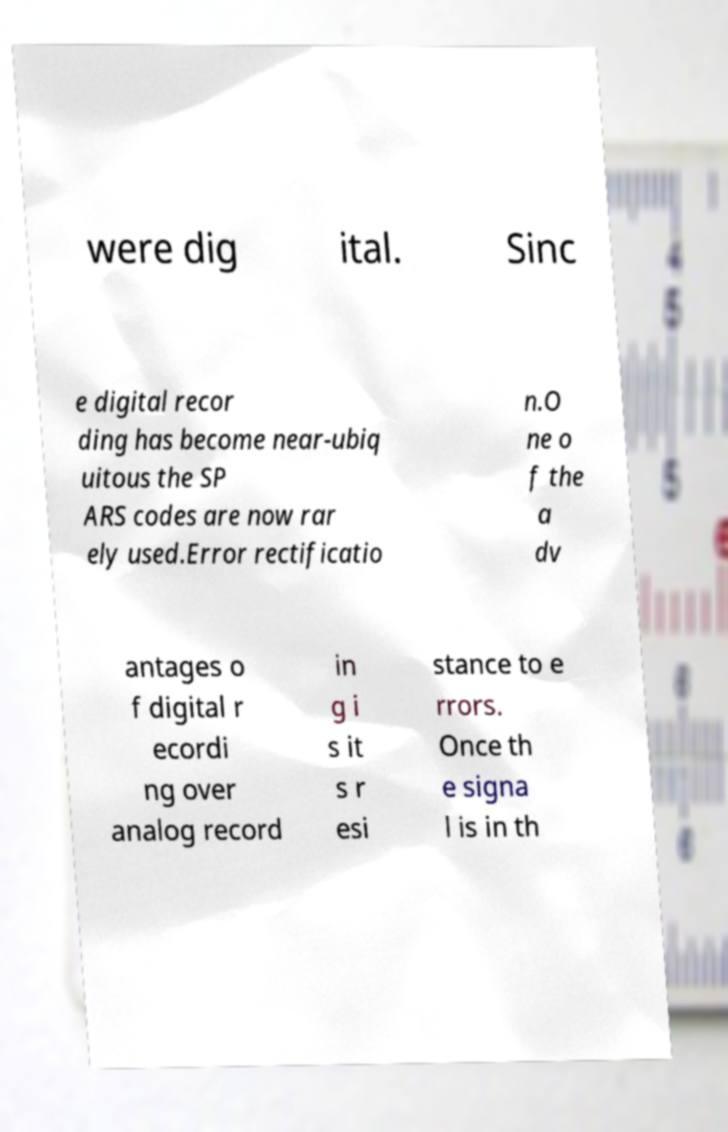Can you accurately transcribe the text from the provided image for me? were dig ital. Sinc e digital recor ding has become near-ubiq uitous the SP ARS codes are now rar ely used.Error rectificatio n.O ne o f the a dv antages o f digital r ecordi ng over analog record in g i s it s r esi stance to e rrors. Once th e signa l is in th 